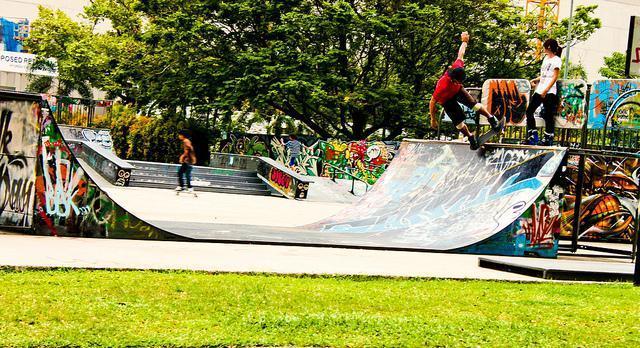How many people can be seen?
Give a very brief answer. 2. 